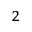Convert formula to latex. <formula><loc_0><loc_0><loc_500><loc_500>^ { 2 }</formula> 